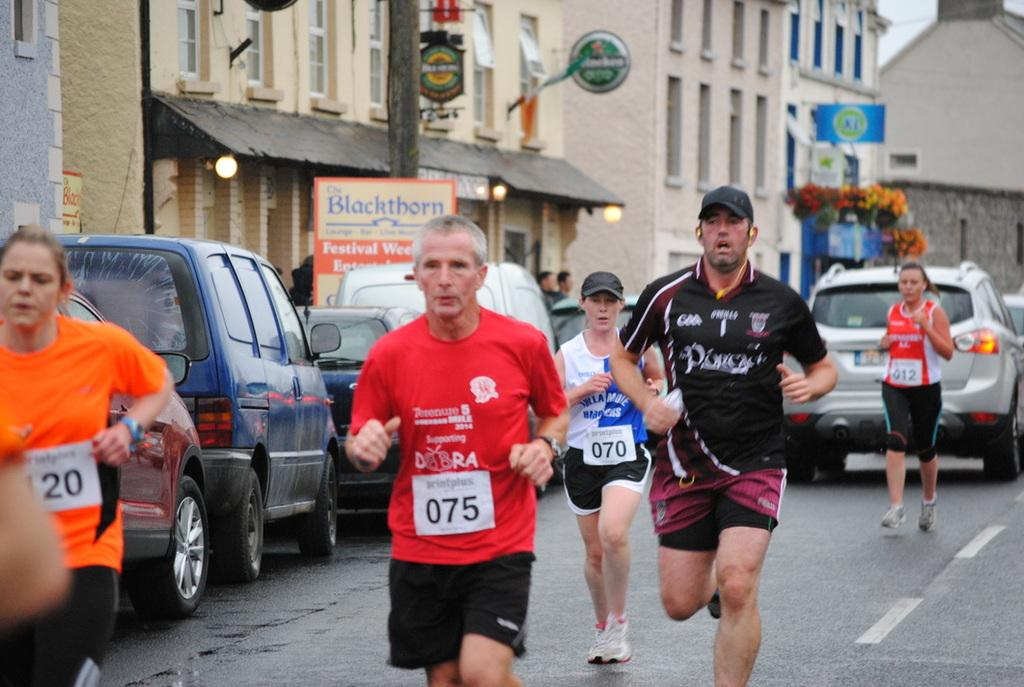<image>
Create a compact narrative representing the image presented. A group of people are running down the street in a race with a man wearing bib number 075. 